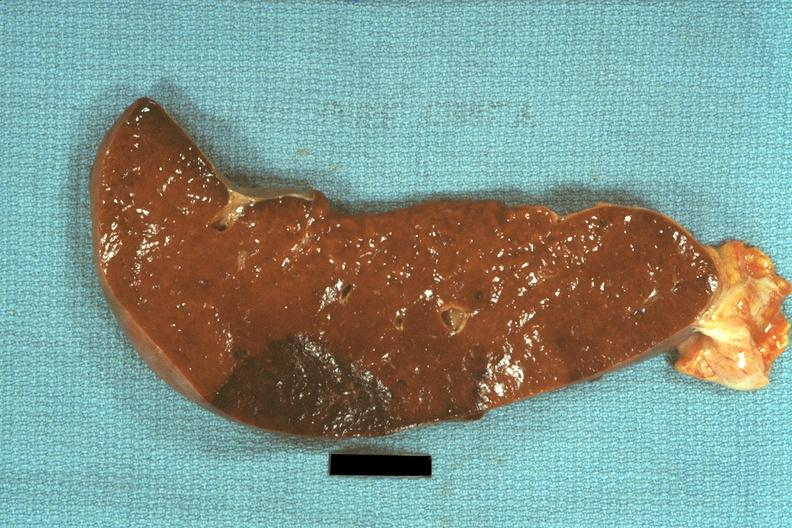where is this part in?
Answer the question using a single word or phrase. Spleen 